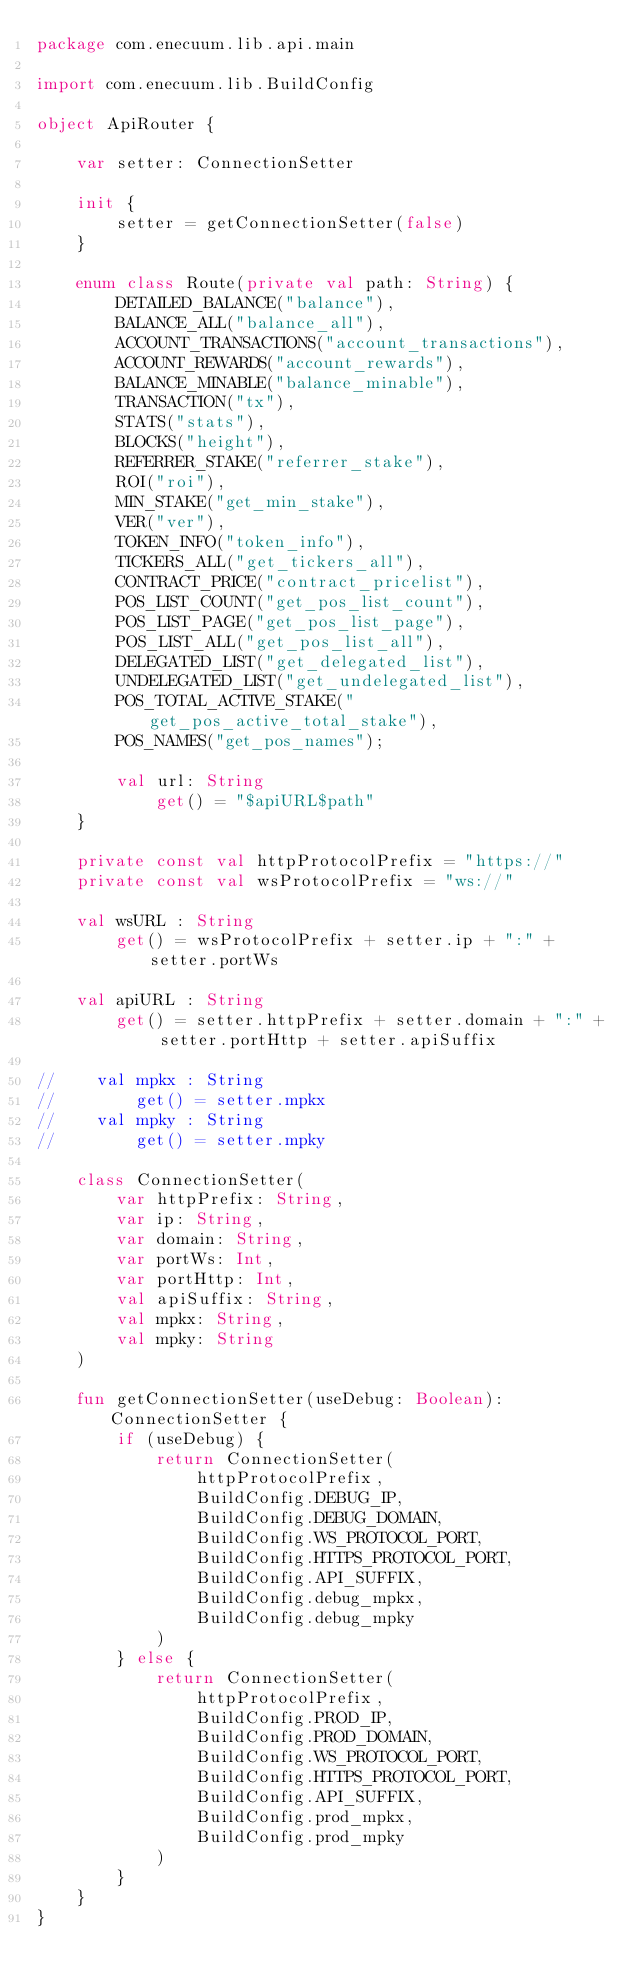<code> <loc_0><loc_0><loc_500><loc_500><_Kotlin_>package com.enecuum.lib.api.main

import com.enecuum.lib.BuildConfig

object ApiRouter {

    var setter: ConnectionSetter

    init {
        setter = getConnectionSetter(false)
    }

    enum class Route(private val path: String) {
        DETAILED_BALANCE("balance"),
        BALANCE_ALL("balance_all"),
        ACCOUNT_TRANSACTIONS("account_transactions"),
        ACCOUNT_REWARDS("account_rewards"),
        BALANCE_MINABLE("balance_minable"),
        TRANSACTION("tx"),
        STATS("stats"),
        BLOCKS("height"),
        REFERRER_STAKE("referrer_stake"),
        ROI("roi"),
        MIN_STAKE("get_min_stake"),
        VER("ver"),
        TOKEN_INFO("token_info"),
        TICKERS_ALL("get_tickers_all"),
        CONTRACT_PRICE("contract_pricelist"),
        POS_LIST_COUNT("get_pos_list_count"),
        POS_LIST_PAGE("get_pos_list_page"),
        POS_LIST_ALL("get_pos_list_all"),
        DELEGATED_LIST("get_delegated_list"),
        UNDELEGATED_LIST("get_undelegated_list"),
        POS_TOTAL_ACTIVE_STAKE("get_pos_active_total_stake"),
        POS_NAMES("get_pos_names");

        val url: String
            get() = "$apiURL$path"
    }

    private const val httpProtocolPrefix = "https://"
    private const val wsProtocolPrefix = "ws://"

    val wsURL : String
        get() = wsProtocolPrefix + setter.ip + ":" + setter.portWs

    val apiURL : String
        get() = setter.httpPrefix + setter.domain + ":" + setter.portHttp + setter.apiSuffix

//    val mpkx : String
//        get() = setter.mpkx
//    val mpky : String
//        get() = setter.mpky

    class ConnectionSetter(
        var httpPrefix: String,
        var ip: String,
        var domain: String,
        var portWs: Int,
        var portHttp: Int,
        val apiSuffix: String,
        val mpkx: String,
        val mpky: String
    )

    fun getConnectionSetter(useDebug: Boolean): ConnectionSetter {
        if (useDebug) {
            return ConnectionSetter(
                httpProtocolPrefix,
                BuildConfig.DEBUG_IP,
                BuildConfig.DEBUG_DOMAIN,
                BuildConfig.WS_PROTOCOL_PORT,
                BuildConfig.HTTPS_PROTOCOL_PORT,
                BuildConfig.API_SUFFIX,
                BuildConfig.debug_mpkx,
                BuildConfig.debug_mpky
            )
        } else {
            return ConnectionSetter(
                httpProtocolPrefix,
                BuildConfig.PROD_IP,
                BuildConfig.PROD_DOMAIN,
                BuildConfig.WS_PROTOCOL_PORT,
                BuildConfig.HTTPS_PROTOCOL_PORT,
                BuildConfig.API_SUFFIX,
                BuildConfig.prod_mpkx,
                BuildConfig.prod_mpky
            )
        }
    }
}</code> 